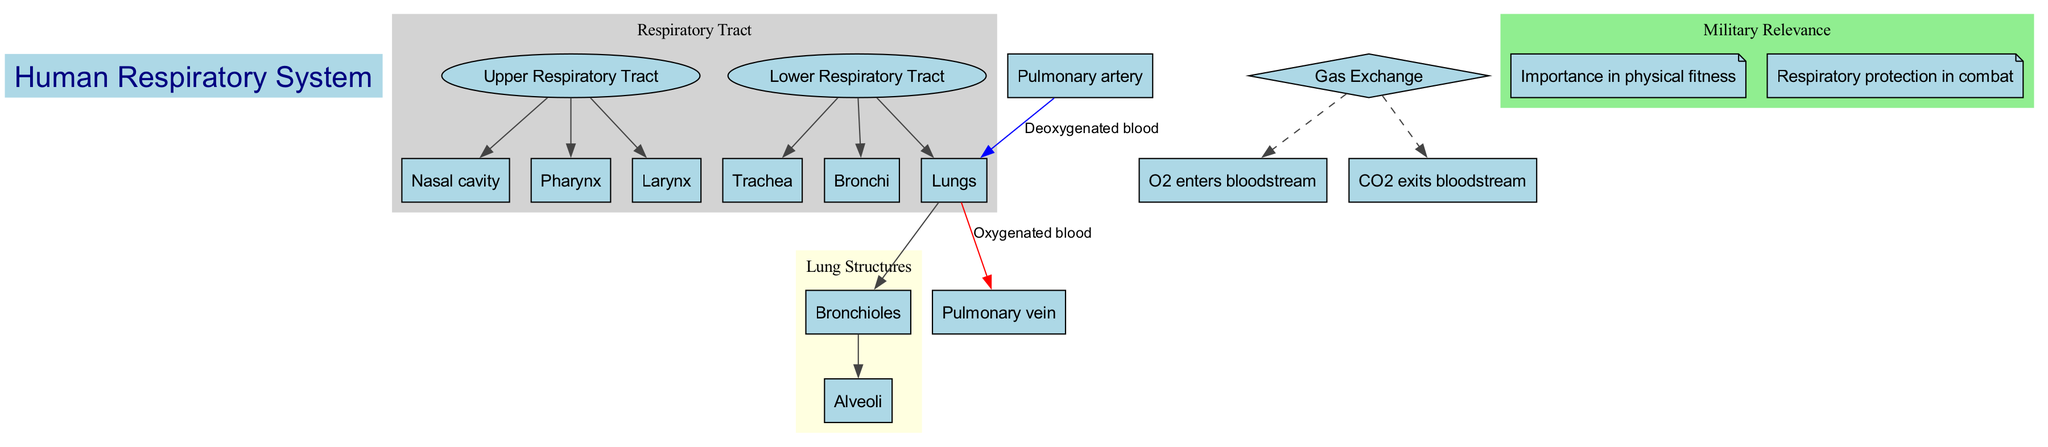What are the three main parts of the Upper Respiratory Tract? The diagram lists three parts: Nasal cavity, Pharynx, and Larynx, which are directly labeled in the section of the Upper Respiratory Tract.
Answer: Nasal cavity, Pharynx, Larynx How many lung structures are there? The diagram identifies two lung structures, Bronchioles and Alveoli, visually separated within the Lung Structures section.
Answer: 2 What type of blood is carried by the Pulmonary artery? The diagram indicates that the Pulmonary artery carries Deoxygenated blood, as labeled by the edge leading to the lungs from this artery.
Answer: Deoxygenated blood What is the path of Oxygenated blood in the respiratory system? The diagram outlines the path with an arrow, showing that Oxygenated blood flows from the Lungs to the Pulmonary vein. This is deduced from the labeled edge connecting these two nodes.
Answer: Lungs → Pulmonary vein Which structures are involved in gas exchange? The diagram notes that during gas exchange, O2 enters the bloodstream and CO2 exits, represented by dashed edges leading from the Gas Exchange diamond node.
Answer: O2 enters bloodstream, CO2 exits bloodstream What is one reason for military relevance of the respiratory system? The diagram highlights various military relevance points, one of which is the "Importance in physical fitness," clearly labeled in the Military Relevance section.
Answer: Importance in physical fitness What do Bronchioles connect to? The diagram depicts that Bronchioles lead to Alveoli, as indicated by the direct edge drawn from the Bronchioles node to the Alveoli node.
Answer: Alveoli How does Deoxygenated blood enter the lungs? According to the diagram, Deoxygenated blood enters the lungs via the Pulmonary artery, as specified by the labeling on the edge leading to the lungs from this artery.
Answer: Pulmonary artery → Lungs What color represents Oxygenated blood flow in the diagram? The diagram uses red to illustrate the flow of Oxygenated blood, as seen in the edge directed from the Lungs to the Pulmonary vein.
Answer: Red 